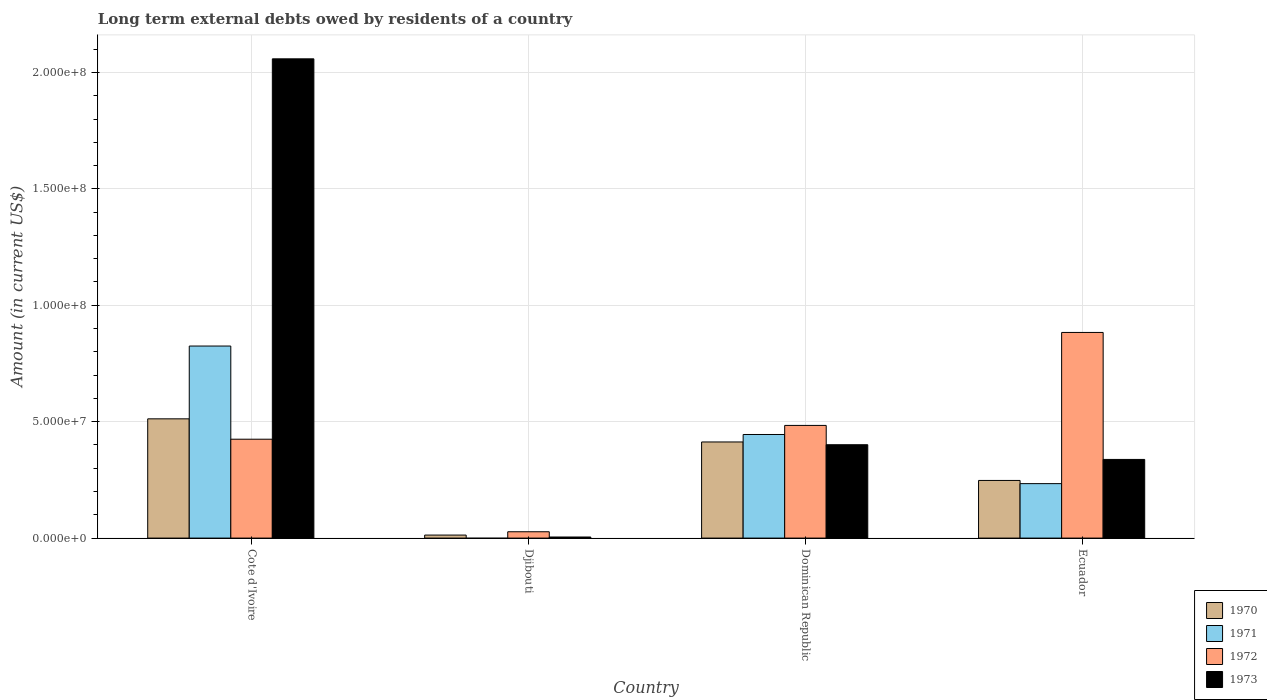How many different coloured bars are there?
Provide a short and direct response. 4. How many groups of bars are there?
Provide a succinct answer. 4. Are the number of bars on each tick of the X-axis equal?
Offer a terse response. No. What is the label of the 4th group of bars from the left?
Offer a very short reply. Ecuador. In how many cases, is the number of bars for a given country not equal to the number of legend labels?
Offer a very short reply. 1. What is the amount of long-term external debts owed by residents in 1971 in Djibouti?
Your response must be concise. 0. Across all countries, what is the maximum amount of long-term external debts owed by residents in 1972?
Make the answer very short. 8.83e+07. Across all countries, what is the minimum amount of long-term external debts owed by residents in 1972?
Provide a short and direct response. 2.72e+06. In which country was the amount of long-term external debts owed by residents in 1972 maximum?
Keep it short and to the point. Ecuador. What is the total amount of long-term external debts owed by residents in 1970 in the graph?
Keep it short and to the point. 1.19e+08. What is the difference between the amount of long-term external debts owed by residents in 1971 in Dominican Republic and that in Ecuador?
Make the answer very short. 2.11e+07. What is the difference between the amount of long-term external debts owed by residents in 1971 in Cote d'Ivoire and the amount of long-term external debts owed by residents in 1972 in Djibouti?
Keep it short and to the point. 7.98e+07. What is the average amount of long-term external debts owed by residents in 1971 per country?
Give a very brief answer. 3.76e+07. What is the difference between the amount of long-term external debts owed by residents of/in 1972 and amount of long-term external debts owed by residents of/in 1973 in Ecuador?
Offer a terse response. 5.45e+07. In how many countries, is the amount of long-term external debts owed by residents in 1973 greater than 190000000 US$?
Provide a short and direct response. 1. What is the ratio of the amount of long-term external debts owed by residents in 1970 in Cote d'Ivoire to that in Ecuador?
Your answer should be very brief. 2.07. What is the difference between the highest and the second highest amount of long-term external debts owed by residents in 1973?
Offer a terse response. 1.72e+08. What is the difference between the highest and the lowest amount of long-term external debts owed by residents in 1971?
Give a very brief answer. 8.25e+07. Is it the case that in every country, the sum of the amount of long-term external debts owed by residents in 1973 and amount of long-term external debts owed by residents in 1971 is greater than the sum of amount of long-term external debts owed by residents in 1972 and amount of long-term external debts owed by residents in 1970?
Ensure brevity in your answer.  No. How many countries are there in the graph?
Provide a succinct answer. 4. What is the difference between two consecutive major ticks on the Y-axis?
Your answer should be compact. 5.00e+07. Does the graph contain any zero values?
Your answer should be very brief. Yes. How many legend labels are there?
Offer a very short reply. 4. What is the title of the graph?
Offer a very short reply. Long term external debts owed by residents of a country. What is the label or title of the Y-axis?
Ensure brevity in your answer.  Amount (in current US$). What is the Amount (in current US$) in 1970 in Cote d'Ivoire?
Your response must be concise. 5.12e+07. What is the Amount (in current US$) in 1971 in Cote d'Ivoire?
Make the answer very short. 8.25e+07. What is the Amount (in current US$) in 1972 in Cote d'Ivoire?
Provide a succinct answer. 4.25e+07. What is the Amount (in current US$) of 1973 in Cote d'Ivoire?
Offer a terse response. 2.06e+08. What is the Amount (in current US$) of 1970 in Djibouti?
Make the answer very short. 1.30e+06. What is the Amount (in current US$) of 1971 in Djibouti?
Keep it short and to the point. 0. What is the Amount (in current US$) in 1972 in Djibouti?
Offer a terse response. 2.72e+06. What is the Amount (in current US$) in 1973 in Djibouti?
Make the answer very short. 4.68e+05. What is the Amount (in current US$) of 1970 in Dominican Republic?
Provide a succinct answer. 4.13e+07. What is the Amount (in current US$) in 1971 in Dominican Republic?
Offer a very short reply. 4.45e+07. What is the Amount (in current US$) in 1972 in Dominican Republic?
Ensure brevity in your answer.  4.84e+07. What is the Amount (in current US$) of 1973 in Dominican Republic?
Give a very brief answer. 4.01e+07. What is the Amount (in current US$) of 1970 in Ecuador?
Offer a very short reply. 2.48e+07. What is the Amount (in current US$) of 1971 in Ecuador?
Give a very brief answer. 2.34e+07. What is the Amount (in current US$) of 1972 in Ecuador?
Your response must be concise. 8.83e+07. What is the Amount (in current US$) of 1973 in Ecuador?
Give a very brief answer. 3.38e+07. Across all countries, what is the maximum Amount (in current US$) in 1970?
Your response must be concise. 5.12e+07. Across all countries, what is the maximum Amount (in current US$) of 1971?
Your answer should be very brief. 8.25e+07. Across all countries, what is the maximum Amount (in current US$) of 1972?
Offer a terse response. 8.83e+07. Across all countries, what is the maximum Amount (in current US$) in 1973?
Give a very brief answer. 2.06e+08. Across all countries, what is the minimum Amount (in current US$) in 1970?
Make the answer very short. 1.30e+06. Across all countries, what is the minimum Amount (in current US$) in 1972?
Your response must be concise. 2.72e+06. Across all countries, what is the minimum Amount (in current US$) in 1973?
Keep it short and to the point. 4.68e+05. What is the total Amount (in current US$) in 1970 in the graph?
Your answer should be very brief. 1.19e+08. What is the total Amount (in current US$) in 1971 in the graph?
Ensure brevity in your answer.  1.50e+08. What is the total Amount (in current US$) of 1972 in the graph?
Keep it short and to the point. 1.82e+08. What is the total Amount (in current US$) of 1973 in the graph?
Give a very brief answer. 2.80e+08. What is the difference between the Amount (in current US$) in 1970 in Cote d'Ivoire and that in Djibouti?
Make the answer very short. 4.99e+07. What is the difference between the Amount (in current US$) in 1972 in Cote d'Ivoire and that in Djibouti?
Provide a succinct answer. 3.98e+07. What is the difference between the Amount (in current US$) in 1973 in Cote d'Ivoire and that in Djibouti?
Your answer should be very brief. 2.05e+08. What is the difference between the Amount (in current US$) of 1970 in Cote d'Ivoire and that in Dominican Republic?
Make the answer very short. 9.93e+06. What is the difference between the Amount (in current US$) of 1971 in Cote d'Ivoire and that in Dominican Republic?
Make the answer very short. 3.80e+07. What is the difference between the Amount (in current US$) of 1972 in Cote d'Ivoire and that in Dominican Republic?
Keep it short and to the point. -5.92e+06. What is the difference between the Amount (in current US$) of 1973 in Cote d'Ivoire and that in Dominican Republic?
Make the answer very short. 1.66e+08. What is the difference between the Amount (in current US$) in 1970 in Cote d'Ivoire and that in Ecuador?
Provide a short and direct response. 2.65e+07. What is the difference between the Amount (in current US$) in 1971 in Cote d'Ivoire and that in Ecuador?
Make the answer very short. 5.91e+07. What is the difference between the Amount (in current US$) in 1972 in Cote d'Ivoire and that in Ecuador?
Provide a short and direct response. -4.59e+07. What is the difference between the Amount (in current US$) of 1973 in Cote d'Ivoire and that in Ecuador?
Offer a very short reply. 1.72e+08. What is the difference between the Amount (in current US$) in 1970 in Djibouti and that in Dominican Republic?
Offer a very short reply. -4.00e+07. What is the difference between the Amount (in current US$) in 1972 in Djibouti and that in Dominican Republic?
Give a very brief answer. -4.57e+07. What is the difference between the Amount (in current US$) of 1973 in Djibouti and that in Dominican Republic?
Ensure brevity in your answer.  -3.96e+07. What is the difference between the Amount (in current US$) in 1970 in Djibouti and that in Ecuador?
Offer a terse response. -2.35e+07. What is the difference between the Amount (in current US$) in 1972 in Djibouti and that in Ecuador?
Ensure brevity in your answer.  -8.56e+07. What is the difference between the Amount (in current US$) of 1973 in Djibouti and that in Ecuador?
Keep it short and to the point. -3.33e+07. What is the difference between the Amount (in current US$) of 1970 in Dominican Republic and that in Ecuador?
Offer a very short reply. 1.65e+07. What is the difference between the Amount (in current US$) of 1971 in Dominican Republic and that in Ecuador?
Your answer should be compact. 2.11e+07. What is the difference between the Amount (in current US$) in 1972 in Dominican Republic and that in Ecuador?
Provide a short and direct response. -3.99e+07. What is the difference between the Amount (in current US$) in 1973 in Dominican Republic and that in Ecuador?
Your answer should be very brief. 6.31e+06. What is the difference between the Amount (in current US$) of 1970 in Cote d'Ivoire and the Amount (in current US$) of 1972 in Djibouti?
Your answer should be compact. 4.85e+07. What is the difference between the Amount (in current US$) of 1970 in Cote d'Ivoire and the Amount (in current US$) of 1973 in Djibouti?
Offer a very short reply. 5.08e+07. What is the difference between the Amount (in current US$) in 1971 in Cote d'Ivoire and the Amount (in current US$) in 1972 in Djibouti?
Give a very brief answer. 7.98e+07. What is the difference between the Amount (in current US$) of 1971 in Cote d'Ivoire and the Amount (in current US$) of 1973 in Djibouti?
Provide a succinct answer. 8.20e+07. What is the difference between the Amount (in current US$) in 1972 in Cote d'Ivoire and the Amount (in current US$) in 1973 in Djibouti?
Make the answer very short. 4.20e+07. What is the difference between the Amount (in current US$) in 1970 in Cote d'Ivoire and the Amount (in current US$) in 1971 in Dominican Republic?
Ensure brevity in your answer.  6.73e+06. What is the difference between the Amount (in current US$) in 1970 in Cote d'Ivoire and the Amount (in current US$) in 1972 in Dominican Republic?
Provide a succinct answer. 2.83e+06. What is the difference between the Amount (in current US$) of 1970 in Cote d'Ivoire and the Amount (in current US$) of 1973 in Dominican Republic?
Ensure brevity in your answer.  1.11e+07. What is the difference between the Amount (in current US$) of 1971 in Cote d'Ivoire and the Amount (in current US$) of 1972 in Dominican Republic?
Give a very brief answer. 3.41e+07. What is the difference between the Amount (in current US$) in 1971 in Cote d'Ivoire and the Amount (in current US$) in 1973 in Dominican Republic?
Provide a short and direct response. 4.24e+07. What is the difference between the Amount (in current US$) in 1972 in Cote d'Ivoire and the Amount (in current US$) in 1973 in Dominican Republic?
Ensure brevity in your answer.  2.37e+06. What is the difference between the Amount (in current US$) in 1970 in Cote d'Ivoire and the Amount (in current US$) in 1971 in Ecuador?
Your response must be concise. 2.78e+07. What is the difference between the Amount (in current US$) in 1970 in Cote d'Ivoire and the Amount (in current US$) in 1972 in Ecuador?
Offer a terse response. -3.71e+07. What is the difference between the Amount (in current US$) in 1970 in Cote d'Ivoire and the Amount (in current US$) in 1973 in Ecuador?
Offer a very short reply. 1.74e+07. What is the difference between the Amount (in current US$) of 1971 in Cote d'Ivoire and the Amount (in current US$) of 1972 in Ecuador?
Your answer should be very brief. -5.84e+06. What is the difference between the Amount (in current US$) of 1971 in Cote d'Ivoire and the Amount (in current US$) of 1973 in Ecuador?
Your answer should be very brief. 4.87e+07. What is the difference between the Amount (in current US$) of 1972 in Cote d'Ivoire and the Amount (in current US$) of 1973 in Ecuador?
Make the answer very short. 8.68e+06. What is the difference between the Amount (in current US$) in 1970 in Djibouti and the Amount (in current US$) in 1971 in Dominican Republic?
Your response must be concise. -4.32e+07. What is the difference between the Amount (in current US$) of 1970 in Djibouti and the Amount (in current US$) of 1972 in Dominican Republic?
Provide a short and direct response. -4.71e+07. What is the difference between the Amount (in current US$) of 1970 in Djibouti and the Amount (in current US$) of 1973 in Dominican Republic?
Offer a very short reply. -3.88e+07. What is the difference between the Amount (in current US$) of 1972 in Djibouti and the Amount (in current US$) of 1973 in Dominican Republic?
Keep it short and to the point. -3.74e+07. What is the difference between the Amount (in current US$) in 1970 in Djibouti and the Amount (in current US$) in 1971 in Ecuador?
Provide a succinct answer. -2.21e+07. What is the difference between the Amount (in current US$) in 1970 in Djibouti and the Amount (in current US$) in 1972 in Ecuador?
Ensure brevity in your answer.  -8.70e+07. What is the difference between the Amount (in current US$) in 1970 in Djibouti and the Amount (in current US$) in 1973 in Ecuador?
Keep it short and to the point. -3.25e+07. What is the difference between the Amount (in current US$) of 1972 in Djibouti and the Amount (in current US$) of 1973 in Ecuador?
Make the answer very short. -3.11e+07. What is the difference between the Amount (in current US$) in 1970 in Dominican Republic and the Amount (in current US$) in 1971 in Ecuador?
Your answer should be compact. 1.79e+07. What is the difference between the Amount (in current US$) in 1970 in Dominican Republic and the Amount (in current US$) in 1972 in Ecuador?
Offer a terse response. -4.70e+07. What is the difference between the Amount (in current US$) in 1970 in Dominican Republic and the Amount (in current US$) in 1973 in Ecuador?
Make the answer very short. 7.50e+06. What is the difference between the Amount (in current US$) in 1971 in Dominican Republic and the Amount (in current US$) in 1972 in Ecuador?
Make the answer very short. -4.38e+07. What is the difference between the Amount (in current US$) of 1971 in Dominican Republic and the Amount (in current US$) of 1973 in Ecuador?
Provide a succinct answer. 1.07e+07. What is the difference between the Amount (in current US$) in 1972 in Dominican Republic and the Amount (in current US$) in 1973 in Ecuador?
Provide a short and direct response. 1.46e+07. What is the average Amount (in current US$) in 1970 per country?
Offer a very short reply. 2.96e+07. What is the average Amount (in current US$) in 1971 per country?
Give a very brief answer. 3.76e+07. What is the average Amount (in current US$) of 1972 per country?
Provide a succinct answer. 4.55e+07. What is the average Amount (in current US$) in 1973 per country?
Your answer should be compact. 7.01e+07. What is the difference between the Amount (in current US$) of 1970 and Amount (in current US$) of 1971 in Cote d'Ivoire?
Ensure brevity in your answer.  -3.13e+07. What is the difference between the Amount (in current US$) of 1970 and Amount (in current US$) of 1972 in Cote d'Ivoire?
Provide a short and direct response. 8.75e+06. What is the difference between the Amount (in current US$) in 1970 and Amount (in current US$) in 1973 in Cote d'Ivoire?
Keep it short and to the point. -1.55e+08. What is the difference between the Amount (in current US$) in 1971 and Amount (in current US$) in 1972 in Cote d'Ivoire?
Offer a very short reply. 4.00e+07. What is the difference between the Amount (in current US$) in 1971 and Amount (in current US$) in 1973 in Cote d'Ivoire?
Your answer should be very brief. -1.23e+08. What is the difference between the Amount (in current US$) of 1972 and Amount (in current US$) of 1973 in Cote d'Ivoire?
Your response must be concise. -1.63e+08. What is the difference between the Amount (in current US$) in 1970 and Amount (in current US$) in 1972 in Djibouti?
Your response must be concise. -1.42e+06. What is the difference between the Amount (in current US$) of 1970 and Amount (in current US$) of 1973 in Djibouti?
Make the answer very short. 8.32e+05. What is the difference between the Amount (in current US$) in 1972 and Amount (in current US$) in 1973 in Djibouti?
Provide a short and direct response. 2.26e+06. What is the difference between the Amount (in current US$) of 1970 and Amount (in current US$) of 1971 in Dominican Republic?
Give a very brief answer. -3.21e+06. What is the difference between the Amount (in current US$) in 1970 and Amount (in current US$) in 1972 in Dominican Republic?
Offer a terse response. -7.11e+06. What is the difference between the Amount (in current US$) in 1970 and Amount (in current US$) in 1973 in Dominican Republic?
Make the answer very short. 1.19e+06. What is the difference between the Amount (in current US$) of 1971 and Amount (in current US$) of 1972 in Dominican Republic?
Ensure brevity in your answer.  -3.90e+06. What is the difference between the Amount (in current US$) in 1971 and Amount (in current US$) in 1973 in Dominican Republic?
Keep it short and to the point. 4.39e+06. What is the difference between the Amount (in current US$) in 1972 and Amount (in current US$) in 1973 in Dominican Republic?
Your answer should be compact. 8.29e+06. What is the difference between the Amount (in current US$) of 1970 and Amount (in current US$) of 1971 in Ecuador?
Offer a very short reply. 1.37e+06. What is the difference between the Amount (in current US$) of 1970 and Amount (in current US$) of 1972 in Ecuador?
Offer a very short reply. -6.36e+07. What is the difference between the Amount (in current US$) of 1970 and Amount (in current US$) of 1973 in Ecuador?
Your answer should be compact. -9.03e+06. What is the difference between the Amount (in current US$) in 1971 and Amount (in current US$) in 1972 in Ecuador?
Your response must be concise. -6.49e+07. What is the difference between the Amount (in current US$) in 1971 and Amount (in current US$) in 1973 in Ecuador?
Provide a succinct answer. -1.04e+07. What is the difference between the Amount (in current US$) in 1972 and Amount (in current US$) in 1973 in Ecuador?
Provide a short and direct response. 5.45e+07. What is the ratio of the Amount (in current US$) in 1970 in Cote d'Ivoire to that in Djibouti?
Offer a very short reply. 39.4. What is the ratio of the Amount (in current US$) of 1972 in Cote d'Ivoire to that in Djibouti?
Offer a terse response. 15.6. What is the ratio of the Amount (in current US$) in 1973 in Cote d'Ivoire to that in Djibouti?
Provide a short and direct response. 439.86. What is the ratio of the Amount (in current US$) of 1970 in Cote d'Ivoire to that in Dominican Republic?
Offer a terse response. 1.24. What is the ratio of the Amount (in current US$) in 1971 in Cote d'Ivoire to that in Dominican Republic?
Offer a very short reply. 1.85. What is the ratio of the Amount (in current US$) of 1972 in Cote d'Ivoire to that in Dominican Republic?
Give a very brief answer. 0.88. What is the ratio of the Amount (in current US$) in 1973 in Cote d'Ivoire to that in Dominican Republic?
Your response must be concise. 5.13. What is the ratio of the Amount (in current US$) of 1970 in Cote d'Ivoire to that in Ecuador?
Make the answer very short. 2.07. What is the ratio of the Amount (in current US$) of 1971 in Cote d'Ivoire to that in Ecuador?
Offer a very short reply. 3.53. What is the ratio of the Amount (in current US$) in 1972 in Cote d'Ivoire to that in Ecuador?
Provide a succinct answer. 0.48. What is the ratio of the Amount (in current US$) in 1973 in Cote d'Ivoire to that in Ecuador?
Provide a short and direct response. 6.09. What is the ratio of the Amount (in current US$) of 1970 in Djibouti to that in Dominican Republic?
Provide a succinct answer. 0.03. What is the ratio of the Amount (in current US$) of 1972 in Djibouti to that in Dominican Republic?
Provide a succinct answer. 0.06. What is the ratio of the Amount (in current US$) of 1973 in Djibouti to that in Dominican Republic?
Your answer should be very brief. 0.01. What is the ratio of the Amount (in current US$) of 1970 in Djibouti to that in Ecuador?
Provide a short and direct response. 0.05. What is the ratio of the Amount (in current US$) in 1972 in Djibouti to that in Ecuador?
Give a very brief answer. 0.03. What is the ratio of the Amount (in current US$) of 1973 in Djibouti to that in Ecuador?
Your answer should be compact. 0.01. What is the ratio of the Amount (in current US$) in 1970 in Dominican Republic to that in Ecuador?
Make the answer very short. 1.67. What is the ratio of the Amount (in current US$) of 1971 in Dominican Republic to that in Ecuador?
Provide a short and direct response. 1.9. What is the ratio of the Amount (in current US$) in 1972 in Dominican Republic to that in Ecuador?
Provide a succinct answer. 0.55. What is the ratio of the Amount (in current US$) of 1973 in Dominican Republic to that in Ecuador?
Your answer should be compact. 1.19. What is the difference between the highest and the second highest Amount (in current US$) of 1970?
Your response must be concise. 9.93e+06. What is the difference between the highest and the second highest Amount (in current US$) in 1971?
Provide a succinct answer. 3.80e+07. What is the difference between the highest and the second highest Amount (in current US$) of 1972?
Keep it short and to the point. 3.99e+07. What is the difference between the highest and the second highest Amount (in current US$) in 1973?
Provide a succinct answer. 1.66e+08. What is the difference between the highest and the lowest Amount (in current US$) in 1970?
Give a very brief answer. 4.99e+07. What is the difference between the highest and the lowest Amount (in current US$) of 1971?
Offer a terse response. 8.25e+07. What is the difference between the highest and the lowest Amount (in current US$) of 1972?
Your response must be concise. 8.56e+07. What is the difference between the highest and the lowest Amount (in current US$) in 1973?
Your answer should be very brief. 2.05e+08. 